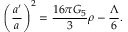<formula> <loc_0><loc_0><loc_500><loc_500>\left ( { \frac { a ^ { \prime } } { a } } \right ) ^ { 2 } = { \frac { 1 6 \pi G _ { 5 } } { 3 } } \rho - { \frac { \Lambda } { 6 } } .</formula> 